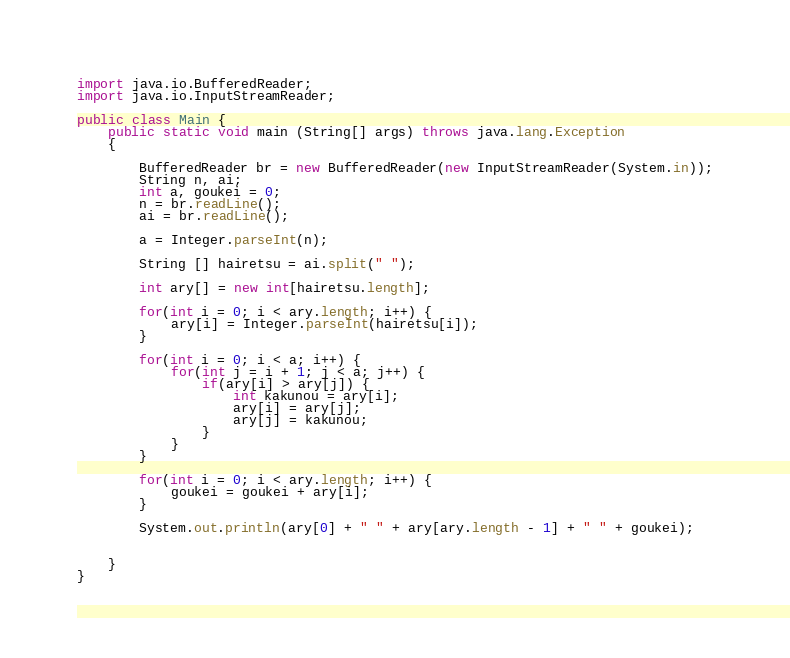Convert code to text. <code><loc_0><loc_0><loc_500><loc_500><_Java_>import java.io.BufferedReader;
import java.io.InputStreamReader;

public class Main {
	public static void main (String[] args) throws java.lang.Exception
	{
		
		BufferedReader br = new BufferedReader(new InputStreamReader(System.in));
		String n, ai;
		int a, goukei = 0;
		n = br.readLine();
		ai = br.readLine();
		
		a = Integer.parseInt(n);
		
		String [] hairetsu = ai.split(" ");
		
		int ary[] = new int[hairetsu.length];
		
		for(int i = 0; i < ary.length; i++) {
			ary[i] = Integer.parseInt(hairetsu[i]);
		}
		
		for(int i = 0; i < a; i++) {
			for(int j = i + 1; j < a; j++) {
				if(ary[i] > ary[j]) {
					int kakunou = ary[i];
					ary[i] = ary[j];
					ary[j] = kakunou;	
				}
			}
		}
		
		for(int i = 0; i < ary.length; i++) {
			goukei = goukei + ary[i];
		}
		
		System.out.println(ary[0] + " " + ary[ary.length - 1] + " " + goukei);
		

	}
}</code> 